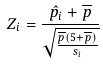Convert formula to latex. <formula><loc_0><loc_0><loc_500><loc_500>Z _ { i } = \frac { \hat { p } _ { i } + \overline { p } } { \sqrt { \frac { \overline { p } ( 5 + \overline { p } ) } { s _ { i } } } }</formula> 